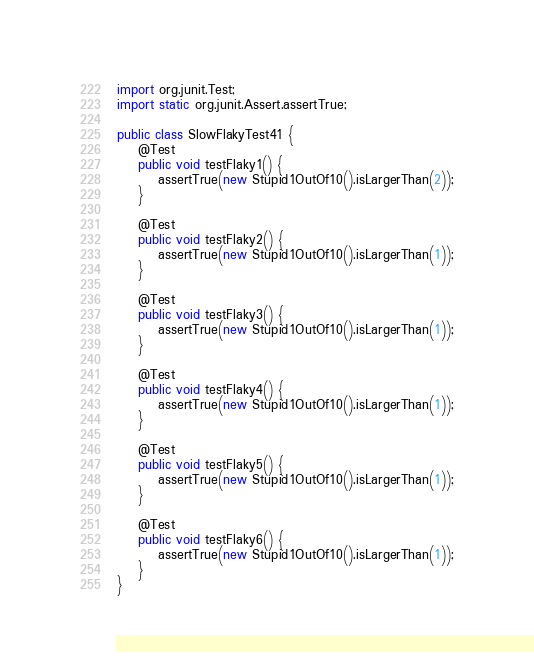<code> <loc_0><loc_0><loc_500><loc_500><_Java_>import org.junit.Test;
import static org.junit.Assert.assertTrue;

public class SlowFlakyTest41 {
    @Test
    public void testFlaky1() {
        assertTrue(new Stupid1OutOf10().isLargerThan(2));
    }

    @Test
    public void testFlaky2() {
        assertTrue(new Stupid1OutOf10().isLargerThan(1));
    }

    @Test
    public void testFlaky3() {
        assertTrue(new Stupid1OutOf10().isLargerThan(1));
    }

    @Test
    public void testFlaky4() {
        assertTrue(new Stupid1OutOf10().isLargerThan(1));
    }

    @Test
    public void testFlaky5() {
        assertTrue(new Stupid1OutOf10().isLargerThan(1));
    }

    @Test
    public void testFlaky6() {
        assertTrue(new Stupid1OutOf10().isLargerThan(1));
    }
}
</code> 